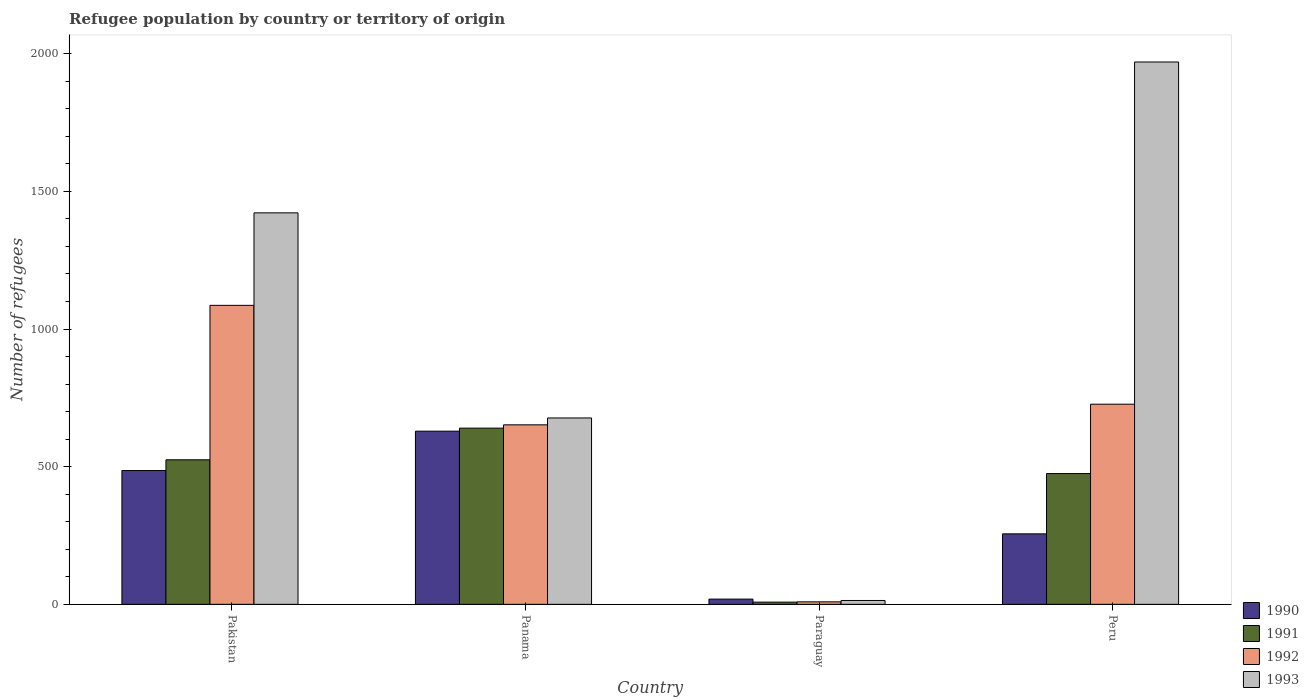How many different coloured bars are there?
Keep it short and to the point. 4. Are the number of bars on each tick of the X-axis equal?
Your answer should be very brief. Yes. How many bars are there on the 4th tick from the left?
Provide a succinct answer. 4. What is the label of the 4th group of bars from the left?
Your answer should be compact. Peru. What is the number of refugees in 1993 in Panama?
Offer a terse response. 677. Across all countries, what is the maximum number of refugees in 1991?
Offer a very short reply. 640. Across all countries, what is the minimum number of refugees in 1990?
Your answer should be compact. 19. In which country was the number of refugees in 1992 minimum?
Your answer should be compact. Paraguay. What is the total number of refugees in 1992 in the graph?
Provide a short and direct response. 2474. What is the difference between the number of refugees in 1990 in Paraguay and that in Peru?
Offer a very short reply. -237. What is the difference between the number of refugees in 1991 in Paraguay and the number of refugees in 1992 in Pakistan?
Keep it short and to the point. -1078. What is the average number of refugees in 1991 per country?
Provide a succinct answer. 412. What is the difference between the number of refugees of/in 1990 and number of refugees of/in 1993 in Pakistan?
Your response must be concise. -936. What is the ratio of the number of refugees in 1990 in Pakistan to that in Paraguay?
Make the answer very short. 25.58. Is the difference between the number of refugees in 1990 in Pakistan and Paraguay greater than the difference between the number of refugees in 1993 in Pakistan and Paraguay?
Provide a short and direct response. No. What is the difference between the highest and the second highest number of refugees in 1991?
Your answer should be very brief. 165. What is the difference between the highest and the lowest number of refugees in 1993?
Keep it short and to the point. 1956. Is the sum of the number of refugees in 1990 in Pakistan and Panama greater than the maximum number of refugees in 1993 across all countries?
Your answer should be very brief. No. What does the 2nd bar from the left in Pakistan represents?
Your answer should be compact. 1991. What does the 2nd bar from the right in Paraguay represents?
Your response must be concise. 1992. How many countries are there in the graph?
Your answer should be very brief. 4. Are the values on the major ticks of Y-axis written in scientific E-notation?
Keep it short and to the point. No. Where does the legend appear in the graph?
Give a very brief answer. Bottom right. How many legend labels are there?
Offer a terse response. 4. How are the legend labels stacked?
Your answer should be very brief. Vertical. What is the title of the graph?
Provide a succinct answer. Refugee population by country or territory of origin. Does "2001" appear as one of the legend labels in the graph?
Provide a succinct answer. No. What is the label or title of the Y-axis?
Offer a terse response. Number of refugees. What is the Number of refugees of 1990 in Pakistan?
Provide a succinct answer. 486. What is the Number of refugees in 1991 in Pakistan?
Keep it short and to the point. 525. What is the Number of refugees of 1992 in Pakistan?
Provide a short and direct response. 1086. What is the Number of refugees in 1993 in Pakistan?
Your answer should be compact. 1422. What is the Number of refugees in 1990 in Panama?
Your response must be concise. 629. What is the Number of refugees in 1991 in Panama?
Your answer should be compact. 640. What is the Number of refugees of 1992 in Panama?
Offer a very short reply. 652. What is the Number of refugees of 1993 in Panama?
Give a very brief answer. 677. What is the Number of refugees of 1992 in Paraguay?
Make the answer very short. 9. What is the Number of refugees of 1993 in Paraguay?
Offer a terse response. 14. What is the Number of refugees of 1990 in Peru?
Make the answer very short. 256. What is the Number of refugees of 1991 in Peru?
Offer a terse response. 475. What is the Number of refugees of 1992 in Peru?
Ensure brevity in your answer.  727. What is the Number of refugees of 1993 in Peru?
Provide a short and direct response. 1970. Across all countries, what is the maximum Number of refugees in 1990?
Provide a succinct answer. 629. Across all countries, what is the maximum Number of refugees in 1991?
Keep it short and to the point. 640. Across all countries, what is the maximum Number of refugees in 1992?
Ensure brevity in your answer.  1086. Across all countries, what is the maximum Number of refugees of 1993?
Your answer should be very brief. 1970. Across all countries, what is the minimum Number of refugees of 1990?
Your response must be concise. 19. Across all countries, what is the minimum Number of refugees in 1991?
Give a very brief answer. 8. What is the total Number of refugees of 1990 in the graph?
Your answer should be compact. 1390. What is the total Number of refugees in 1991 in the graph?
Offer a very short reply. 1648. What is the total Number of refugees of 1992 in the graph?
Your response must be concise. 2474. What is the total Number of refugees of 1993 in the graph?
Provide a succinct answer. 4083. What is the difference between the Number of refugees of 1990 in Pakistan and that in Panama?
Your response must be concise. -143. What is the difference between the Number of refugees in 1991 in Pakistan and that in Panama?
Provide a short and direct response. -115. What is the difference between the Number of refugees in 1992 in Pakistan and that in Panama?
Your answer should be very brief. 434. What is the difference between the Number of refugees of 1993 in Pakistan and that in Panama?
Offer a terse response. 745. What is the difference between the Number of refugees of 1990 in Pakistan and that in Paraguay?
Keep it short and to the point. 467. What is the difference between the Number of refugees of 1991 in Pakistan and that in Paraguay?
Make the answer very short. 517. What is the difference between the Number of refugees in 1992 in Pakistan and that in Paraguay?
Keep it short and to the point. 1077. What is the difference between the Number of refugees of 1993 in Pakistan and that in Paraguay?
Keep it short and to the point. 1408. What is the difference between the Number of refugees in 1990 in Pakistan and that in Peru?
Your answer should be very brief. 230. What is the difference between the Number of refugees in 1991 in Pakistan and that in Peru?
Make the answer very short. 50. What is the difference between the Number of refugees of 1992 in Pakistan and that in Peru?
Your answer should be compact. 359. What is the difference between the Number of refugees in 1993 in Pakistan and that in Peru?
Keep it short and to the point. -548. What is the difference between the Number of refugees in 1990 in Panama and that in Paraguay?
Ensure brevity in your answer.  610. What is the difference between the Number of refugees of 1991 in Panama and that in Paraguay?
Offer a very short reply. 632. What is the difference between the Number of refugees in 1992 in Panama and that in Paraguay?
Ensure brevity in your answer.  643. What is the difference between the Number of refugees in 1993 in Panama and that in Paraguay?
Your response must be concise. 663. What is the difference between the Number of refugees of 1990 in Panama and that in Peru?
Your answer should be compact. 373. What is the difference between the Number of refugees in 1991 in Panama and that in Peru?
Offer a terse response. 165. What is the difference between the Number of refugees of 1992 in Panama and that in Peru?
Your answer should be very brief. -75. What is the difference between the Number of refugees in 1993 in Panama and that in Peru?
Your answer should be compact. -1293. What is the difference between the Number of refugees in 1990 in Paraguay and that in Peru?
Offer a very short reply. -237. What is the difference between the Number of refugees of 1991 in Paraguay and that in Peru?
Make the answer very short. -467. What is the difference between the Number of refugees of 1992 in Paraguay and that in Peru?
Offer a terse response. -718. What is the difference between the Number of refugees in 1993 in Paraguay and that in Peru?
Make the answer very short. -1956. What is the difference between the Number of refugees of 1990 in Pakistan and the Number of refugees of 1991 in Panama?
Offer a terse response. -154. What is the difference between the Number of refugees in 1990 in Pakistan and the Number of refugees in 1992 in Panama?
Offer a terse response. -166. What is the difference between the Number of refugees of 1990 in Pakistan and the Number of refugees of 1993 in Panama?
Ensure brevity in your answer.  -191. What is the difference between the Number of refugees in 1991 in Pakistan and the Number of refugees in 1992 in Panama?
Offer a very short reply. -127. What is the difference between the Number of refugees in 1991 in Pakistan and the Number of refugees in 1993 in Panama?
Give a very brief answer. -152. What is the difference between the Number of refugees of 1992 in Pakistan and the Number of refugees of 1993 in Panama?
Give a very brief answer. 409. What is the difference between the Number of refugees of 1990 in Pakistan and the Number of refugees of 1991 in Paraguay?
Ensure brevity in your answer.  478. What is the difference between the Number of refugees of 1990 in Pakistan and the Number of refugees of 1992 in Paraguay?
Make the answer very short. 477. What is the difference between the Number of refugees in 1990 in Pakistan and the Number of refugees in 1993 in Paraguay?
Offer a terse response. 472. What is the difference between the Number of refugees of 1991 in Pakistan and the Number of refugees of 1992 in Paraguay?
Keep it short and to the point. 516. What is the difference between the Number of refugees in 1991 in Pakistan and the Number of refugees in 1993 in Paraguay?
Your response must be concise. 511. What is the difference between the Number of refugees of 1992 in Pakistan and the Number of refugees of 1993 in Paraguay?
Make the answer very short. 1072. What is the difference between the Number of refugees of 1990 in Pakistan and the Number of refugees of 1991 in Peru?
Offer a terse response. 11. What is the difference between the Number of refugees of 1990 in Pakistan and the Number of refugees of 1992 in Peru?
Your answer should be very brief. -241. What is the difference between the Number of refugees of 1990 in Pakistan and the Number of refugees of 1993 in Peru?
Keep it short and to the point. -1484. What is the difference between the Number of refugees of 1991 in Pakistan and the Number of refugees of 1992 in Peru?
Give a very brief answer. -202. What is the difference between the Number of refugees of 1991 in Pakistan and the Number of refugees of 1993 in Peru?
Provide a short and direct response. -1445. What is the difference between the Number of refugees in 1992 in Pakistan and the Number of refugees in 1993 in Peru?
Give a very brief answer. -884. What is the difference between the Number of refugees of 1990 in Panama and the Number of refugees of 1991 in Paraguay?
Your response must be concise. 621. What is the difference between the Number of refugees in 1990 in Panama and the Number of refugees in 1992 in Paraguay?
Provide a short and direct response. 620. What is the difference between the Number of refugees of 1990 in Panama and the Number of refugees of 1993 in Paraguay?
Make the answer very short. 615. What is the difference between the Number of refugees in 1991 in Panama and the Number of refugees in 1992 in Paraguay?
Your answer should be very brief. 631. What is the difference between the Number of refugees of 1991 in Panama and the Number of refugees of 1993 in Paraguay?
Your response must be concise. 626. What is the difference between the Number of refugees of 1992 in Panama and the Number of refugees of 1993 in Paraguay?
Offer a very short reply. 638. What is the difference between the Number of refugees in 1990 in Panama and the Number of refugees in 1991 in Peru?
Your answer should be very brief. 154. What is the difference between the Number of refugees of 1990 in Panama and the Number of refugees of 1992 in Peru?
Your answer should be very brief. -98. What is the difference between the Number of refugees of 1990 in Panama and the Number of refugees of 1993 in Peru?
Provide a short and direct response. -1341. What is the difference between the Number of refugees in 1991 in Panama and the Number of refugees in 1992 in Peru?
Provide a succinct answer. -87. What is the difference between the Number of refugees of 1991 in Panama and the Number of refugees of 1993 in Peru?
Give a very brief answer. -1330. What is the difference between the Number of refugees of 1992 in Panama and the Number of refugees of 1993 in Peru?
Your answer should be compact. -1318. What is the difference between the Number of refugees in 1990 in Paraguay and the Number of refugees in 1991 in Peru?
Your answer should be very brief. -456. What is the difference between the Number of refugees in 1990 in Paraguay and the Number of refugees in 1992 in Peru?
Provide a succinct answer. -708. What is the difference between the Number of refugees of 1990 in Paraguay and the Number of refugees of 1993 in Peru?
Your response must be concise. -1951. What is the difference between the Number of refugees of 1991 in Paraguay and the Number of refugees of 1992 in Peru?
Provide a short and direct response. -719. What is the difference between the Number of refugees of 1991 in Paraguay and the Number of refugees of 1993 in Peru?
Give a very brief answer. -1962. What is the difference between the Number of refugees in 1992 in Paraguay and the Number of refugees in 1993 in Peru?
Your response must be concise. -1961. What is the average Number of refugees of 1990 per country?
Give a very brief answer. 347.5. What is the average Number of refugees in 1991 per country?
Provide a short and direct response. 412. What is the average Number of refugees of 1992 per country?
Give a very brief answer. 618.5. What is the average Number of refugees in 1993 per country?
Offer a very short reply. 1020.75. What is the difference between the Number of refugees of 1990 and Number of refugees of 1991 in Pakistan?
Offer a terse response. -39. What is the difference between the Number of refugees of 1990 and Number of refugees of 1992 in Pakistan?
Provide a short and direct response. -600. What is the difference between the Number of refugees of 1990 and Number of refugees of 1993 in Pakistan?
Provide a succinct answer. -936. What is the difference between the Number of refugees of 1991 and Number of refugees of 1992 in Pakistan?
Keep it short and to the point. -561. What is the difference between the Number of refugees of 1991 and Number of refugees of 1993 in Pakistan?
Give a very brief answer. -897. What is the difference between the Number of refugees in 1992 and Number of refugees in 1993 in Pakistan?
Provide a short and direct response. -336. What is the difference between the Number of refugees of 1990 and Number of refugees of 1992 in Panama?
Keep it short and to the point. -23. What is the difference between the Number of refugees of 1990 and Number of refugees of 1993 in Panama?
Provide a succinct answer. -48. What is the difference between the Number of refugees in 1991 and Number of refugees in 1993 in Panama?
Provide a succinct answer. -37. What is the difference between the Number of refugees in 1991 and Number of refugees in 1992 in Paraguay?
Ensure brevity in your answer.  -1. What is the difference between the Number of refugees of 1992 and Number of refugees of 1993 in Paraguay?
Keep it short and to the point. -5. What is the difference between the Number of refugees of 1990 and Number of refugees of 1991 in Peru?
Keep it short and to the point. -219. What is the difference between the Number of refugees of 1990 and Number of refugees of 1992 in Peru?
Keep it short and to the point. -471. What is the difference between the Number of refugees in 1990 and Number of refugees in 1993 in Peru?
Provide a short and direct response. -1714. What is the difference between the Number of refugees of 1991 and Number of refugees of 1992 in Peru?
Your answer should be very brief. -252. What is the difference between the Number of refugees of 1991 and Number of refugees of 1993 in Peru?
Keep it short and to the point. -1495. What is the difference between the Number of refugees in 1992 and Number of refugees in 1993 in Peru?
Offer a terse response. -1243. What is the ratio of the Number of refugees of 1990 in Pakistan to that in Panama?
Ensure brevity in your answer.  0.77. What is the ratio of the Number of refugees of 1991 in Pakistan to that in Panama?
Give a very brief answer. 0.82. What is the ratio of the Number of refugees in 1992 in Pakistan to that in Panama?
Offer a terse response. 1.67. What is the ratio of the Number of refugees of 1993 in Pakistan to that in Panama?
Your answer should be very brief. 2.1. What is the ratio of the Number of refugees in 1990 in Pakistan to that in Paraguay?
Ensure brevity in your answer.  25.58. What is the ratio of the Number of refugees of 1991 in Pakistan to that in Paraguay?
Offer a terse response. 65.62. What is the ratio of the Number of refugees in 1992 in Pakistan to that in Paraguay?
Provide a succinct answer. 120.67. What is the ratio of the Number of refugees of 1993 in Pakistan to that in Paraguay?
Offer a very short reply. 101.57. What is the ratio of the Number of refugees in 1990 in Pakistan to that in Peru?
Offer a very short reply. 1.9. What is the ratio of the Number of refugees in 1991 in Pakistan to that in Peru?
Provide a succinct answer. 1.11. What is the ratio of the Number of refugees in 1992 in Pakistan to that in Peru?
Offer a terse response. 1.49. What is the ratio of the Number of refugees in 1993 in Pakistan to that in Peru?
Provide a short and direct response. 0.72. What is the ratio of the Number of refugees in 1990 in Panama to that in Paraguay?
Provide a short and direct response. 33.11. What is the ratio of the Number of refugees in 1992 in Panama to that in Paraguay?
Offer a terse response. 72.44. What is the ratio of the Number of refugees of 1993 in Panama to that in Paraguay?
Give a very brief answer. 48.36. What is the ratio of the Number of refugees of 1990 in Panama to that in Peru?
Your response must be concise. 2.46. What is the ratio of the Number of refugees in 1991 in Panama to that in Peru?
Offer a very short reply. 1.35. What is the ratio of the Number of refugees in 1992 in Panama to that in Peru?
Give a very brief answer. 0.9. What is the ratio of the Number of refugees of 1993 in Panama to that in Peru?
Provide a short and direct response. 0.34. What is the ratio of the Number of refugees in 1990 in Paraguay to that in Peru?
Make the answer very short. 0.07. What is the ratio of the Number of refugees in 1991 in Paraguay to that in Peru?
Keep it short and to the point. 0.02. What is the ratio of the Number of refugees in 1992 in Paraguay to that in Peru?
Make the answer very short. 0.01. What is the ratio of the Number of refugees in 1993 in Paraguay to that in Peru?
Provide a short and direct response. 0.01. What is the difference between the highest and the second highest Number of refugees of 1990?
Keep it short and to the point. 143. What is the difference between the highest and the second highest Number of refugees in 1991?
Provide a succinct answer. 115. What is the difference between the highest and the second highest Number of refugees of 1992?
Offer a very short reply. 359. What is the difference between the highest and the second highest Number of refugees in 1993?
Offer a terse response. 548. What is the difference between the highest and the lowest Number of refugees in 1990?
Your answer should be very brief. 610. What is the difference between the highest and the lowest Number of refugees in 1991?
Your answer should be very brief. 632. What is the difference between the highest and the lowest Number of refugees in 1992?
Offer a terse response. 1077. What is the difference between the highest and the lowest Number of refugees in 1993?
Offer a terse response. 1956. 